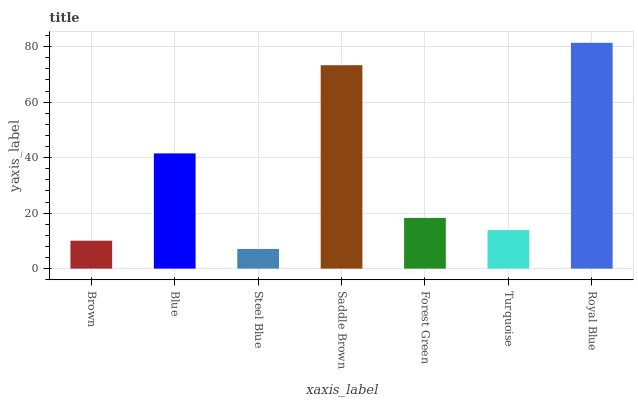Is Steel Blue the minimum?
Answer yes or no. Yes. Is Royal Blue the maximum?
Answer yes or no. Yes. Is Blue the minimum?
Answer yes or no. No. Is Blue the maximum?
Answer yes or no. No. Is Blue greater than Brown?
Answer yes or no. Yes. Is Brown less than Blue?
Answer yes or no. Yes. Is Brown greater than Blue?
Answer yes or no. No. Is Blue less than Brown?
Answer yes or no. No. Is Forest Green the high median?
Answer yes or no. Yes. Is Forest Green the low median?
Answer yes or no. Yes. Is Saddle Brown the high median?
Answer yes or no. No. Is Turquoise the low median?
Answer yes or no. No. 